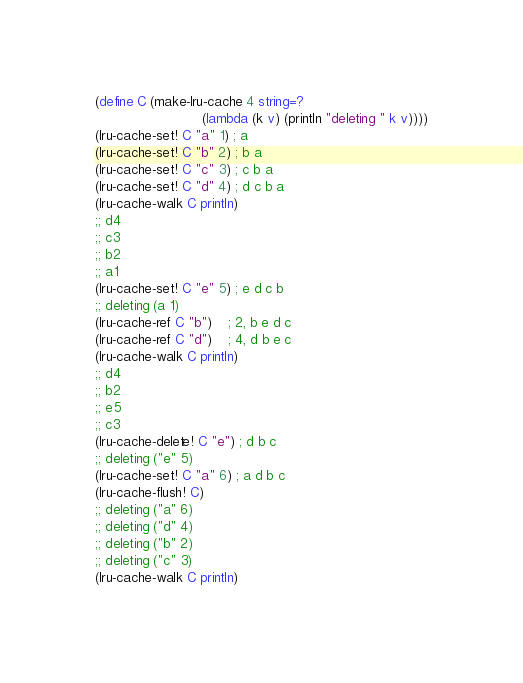<code> <loc_0><loc_0><loc_500><loc_500><_Scheme_>(define C (make-lru-cache 4 string=?
                          (lambda (k v) (println "deleting " k v))))
(lru-cache-set! C "a" 1) ; a
(lru-cache-set! C "b" 2) ; b a
(lru-cache-set! C "c" 3) ; c b a
(lru-cache-set! C "d" 4) ; d c b a
(lru-cache-walk C println)
;; d4
;; c3
;; b2
;; a1
(lru-cache-set! C "e" 5) ; e d c b
;; deleting (a 1)
(lru-cache-ref C "b")    ; 2, b e d c
(lru-cache-ref C "d")    ; 4, d b e c
(lru-cache-walk C println)
;; d4
;; b2
;; e5
;; c3
(lru-cache-delete! C "e") ; d b c
;; deleting ("e" 5)
(lru-cache-set! C "a" 6) ; a d b c
(lru-cache-flush! C)
;; deleting ("a" 6)
;; deleting ("d" 4)
;; deleting ("b" 2)
;; deleting ("c" 3)
(lru-cache-walk C println)
</code> 